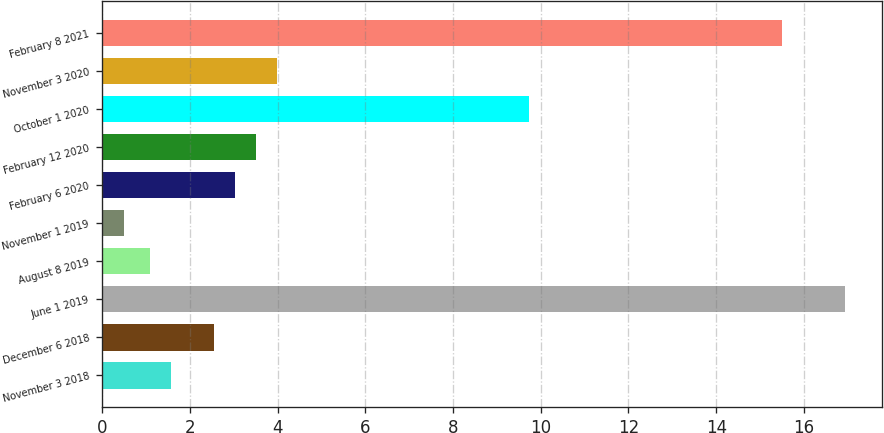Convert chart. <chart><loc_0><loc_0><loc_500><loc_500><bar_chart><fcel>November 3 2018<fcel>December 6 2018<fcel>June 1 2019<fcel>August 8 2019<fcel>November 1 2019<fcel>February 6 2020<fcel>February 12 2020<fcel>October 1 2020<fcel>November 3 2020<fcel>February 8 2021<nl><fcel>1.58<fcel>2.54<fcel>16.94<fcel>1.1<fcel>0.5<fcel>3.02<fcel>3.5<fcel>9.74<fcel>3.98<fcel>15.5<nl></chart> 